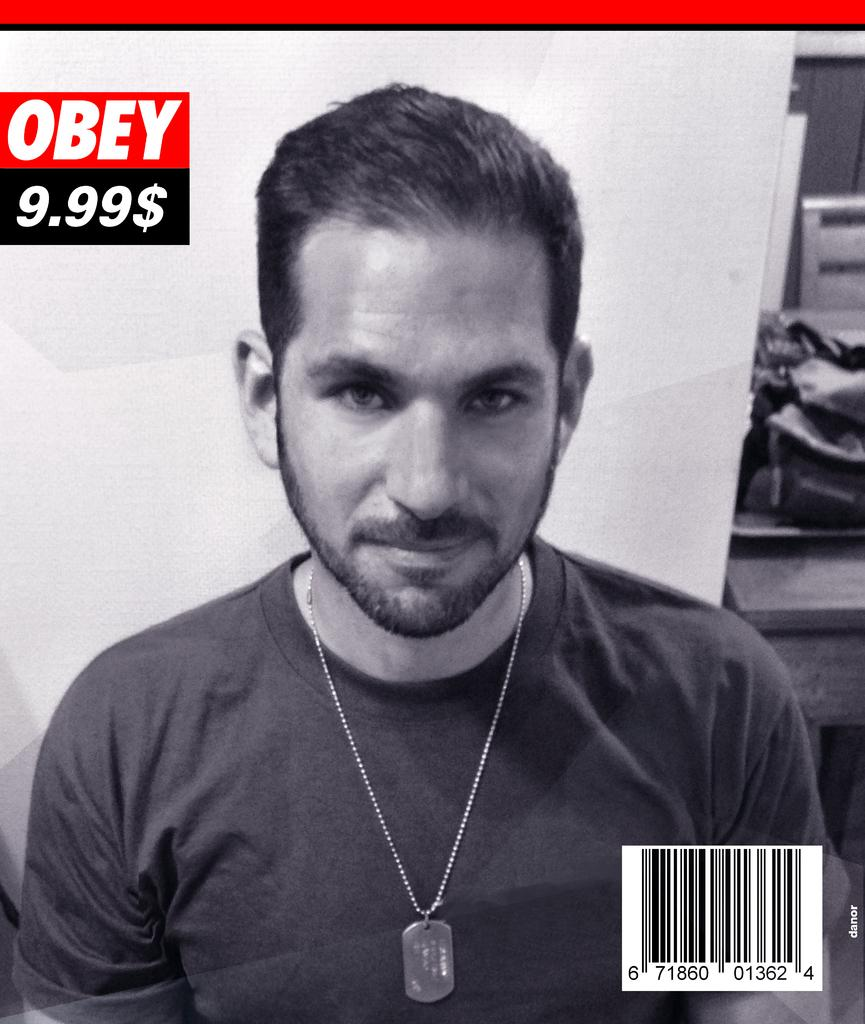What type of visual is the image? The image is a poster. Who is depicted in the image? There is a man in the image. What additional information is present on the poster? There is text and a price on the poster, as well as a barcode in the bottom right corner. What can be seen in the background of the image? There are objects on a table in the background of the image. What type of flowers are being sold on the journey depicted in the image? There are no flowers or journeys depicted in the image; it is a poster featuring a man with text, price, and a barcode. How many beans are visible on the table in the image? There are no beans present in the image; the table in the background has objects, but no beans are visible. 